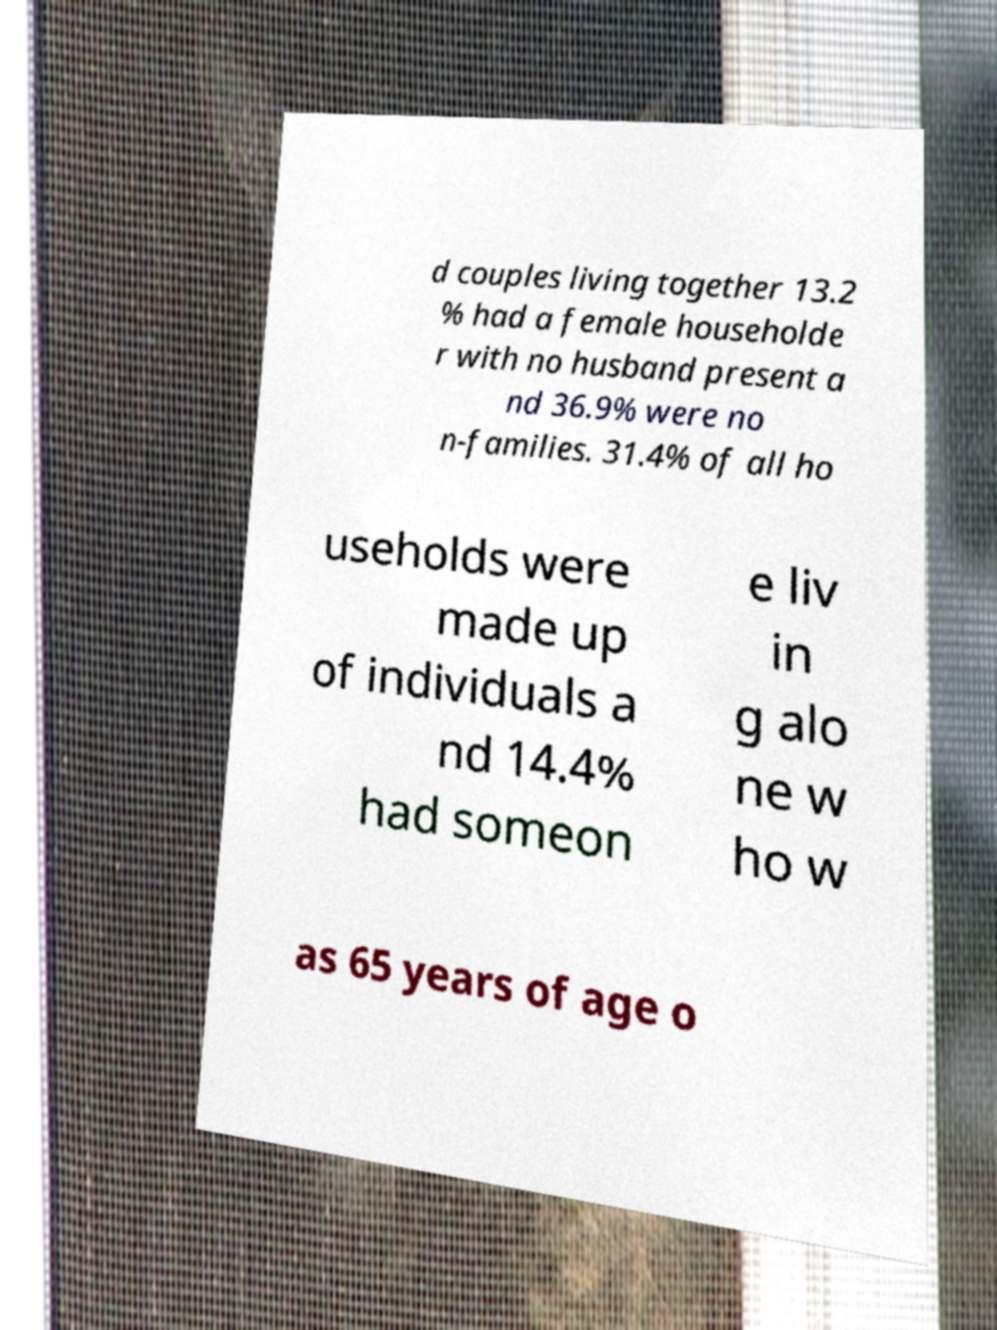I need the written content from this picture converted into text. Can you do that? d couples living together 13.2 % had a female householde r with no husband present a nd 36.9% were no n-families. 31.4% of all ho useholds were made up of individuals a nd 14.4% had someon e liv in g alo ne w ho w as 65 years of age o 